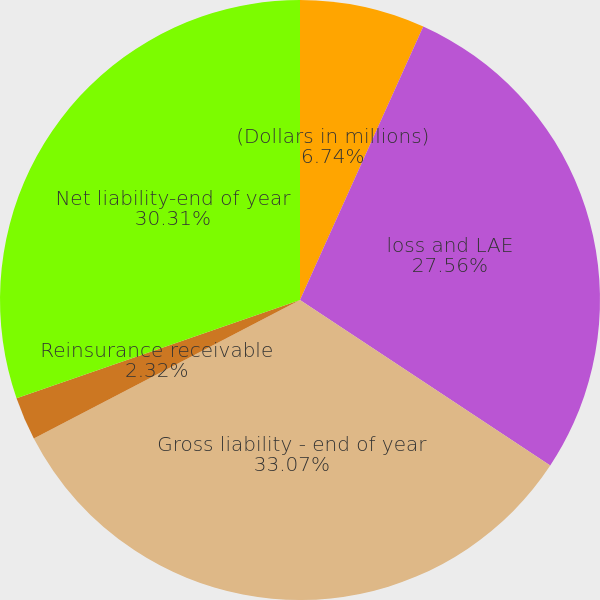<chart> <loc_0><loc_0><loc_500><loc_500><pie_chart><fcel>(Dollars in millions)<fcel>loss and LAE<fcel>Gross liability - end of year<fcel>Reinsurance receivable<fcel>Net liability-end of year<nl><fcel>6.74%<fcel>27.56%<fcel>33.07%<fcel>2.32%<fcel>30.31%<nl></chart> 